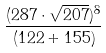<formula> <loc_0><loc_0><loc_500><loc_500>\frac { ( 2 8 7 \cdot \sqrt { 2 0 7 } ) ^ { 8 } } { ( 1 2 2 + 1 5 5 ) }</formula> 